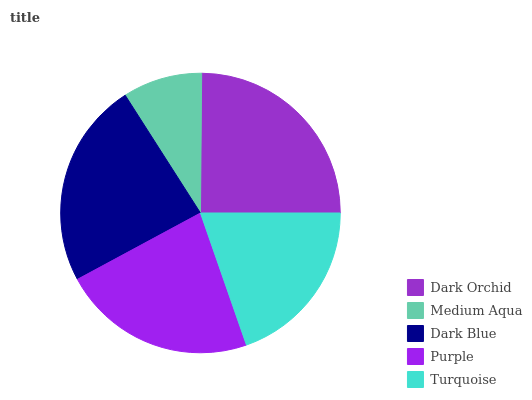Is Medium Aqua the minimum?
Answer yes or no. Yes. Is Dark Orchid the maximum?
Answer yes or no. Yes. Is Dark Blue the minimum?
Answer yes or no. No. Is Dark Blue the maximum?
Answer yes or no. No. Is Dark Blue greater than Medium Aqua?
Answer yes or no. Yes. Is Medium Aqua less than Dark Blue?
Answer yes or no. Yes. Is Medium Aqua greater than Dark Blue?
Answer yes or no. No. Is Dark Blue less than Medium Aqua?
Answer yes or no. No. Is Purple the high median?
Answer yes or no. Yes. Is Purple the low median?
Answer yes or no. Yes. Is Medium Aqua the high median?
Answer yes or no. No. Is Dark Orchid the low median?
Answer yes or no. No. 